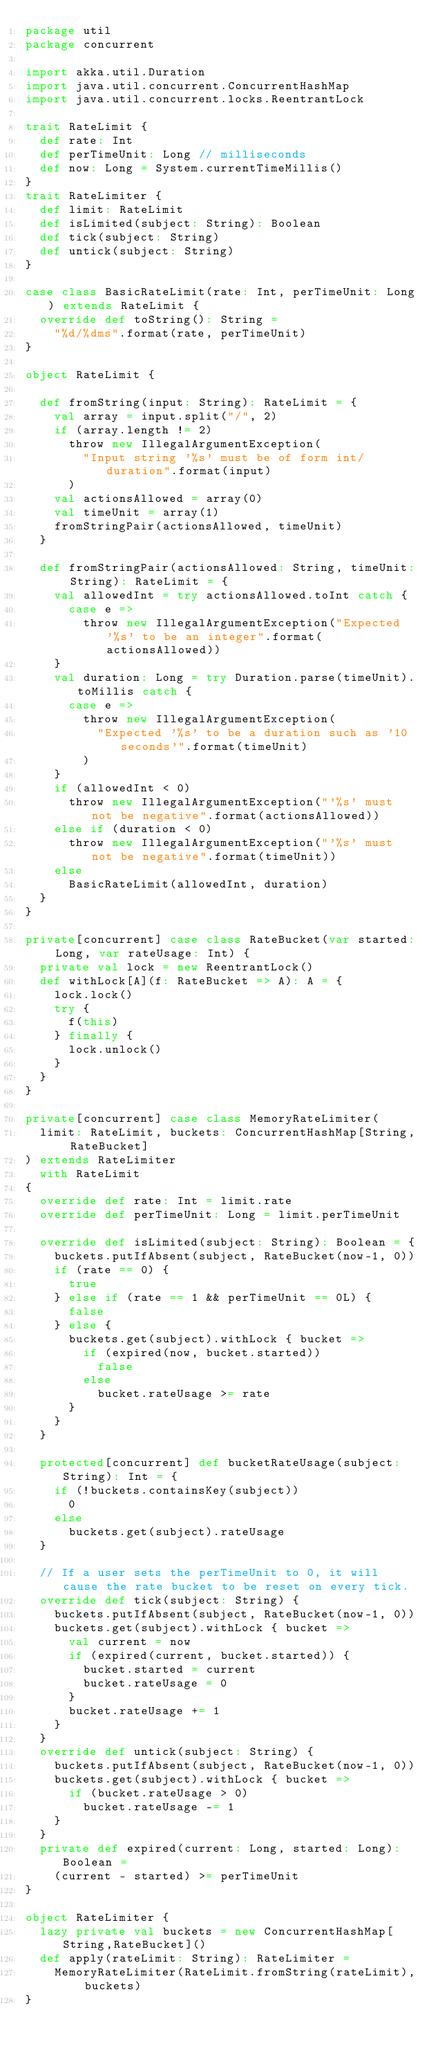<code> <loc_0><loc_0><loc_500><loc_500><_Scala_>package util
package concurrent

import akka.util.Duration
import java.util.concurrent.ConcurrentHashMap
import java.util.concurrent.locks.ReentrantLock

trait RateLimit {
  def rate: Int
  def perTimeUnit: Long // milliseconds
  def now: Long = System.currentTimeMillis()
}
trait RateLimiter {
  def limit: RateLimit
  def isLimited(subject: String): Boolean
  def tick(subject: String)
  def untick(subject: String)
}

case class BasicRateLimit(rate: Int, perTimeUnit: Long) extends RateLimit {
  override def toString(): String =
    "%d/%dms".format(rate, perTimeUnit)
}

object RateLimit {

  def fromString(input: String): RateLimit = {
    val array = input.split("/", 2)
    if (array.length != 2)
      throw new IllegalArgumentException(
        "Input string '%s' must be of form int/duration".format(input)
      )
    val actionsAllowed = array(0)
    val timeUnit = array(1)
    fromStringPair(actionsAllowed, timeUnit)
  }

  def fromStringPair(actionsAllowed: String, timeUnit: String): RateLimit = {
    val allowedInt = try actionsAllowed.toInt catch {
      case e =>
        throw new IllegalArgumentException("Expected '%s' to be an integer".format(actionsAllowed))
    }
    val duration: Long = try Duration.parse(timeUnit).toMillis catch {
      case e =>
        throw new IllegalArgumentException(
          "Expected '%s' to be a duration such as '10 seconds'".format(timeUnit)
        )
    }
    if (allowedInt < 0)
      throw new IllegalArgumentException("'%s' must not be negative".format(actionsAllowed))
    else if (duration < 0)
      throw new IllegalArgumentException("'%s' must not be negative".format(timeUnit))
    else
      BasicRateLimit(allowedInt, duration)
  }
}

private[concurrent] case class RateBucket(var started: Long, var rateUsage: Int) {
  private val lock = new ReentrantLock()
  def withLock[A](f: RateBucket => A): A = {
    lock.lock()
    try {
      f(this)
    } finally {
      lock.unlock()
    }
  }
}

private[concurrent] case class MemoryRateLimiter(
  limit: RateLimit, buckets: ConcurrentHashMap[String, RateBucket]
) extends RateLimiter
  with RateLimit
{
  override def rate: Int = limit.rate
  override def perTimeUnit: Long = limit.perTimeUnit

  override def isLimited(subject: String): Boolean = {
    buckets.putIfAbsent(subject, RateBucket(now-1, 0))
    if (rate == 0) {
      true
    } else if (rate == 1 && perTimeUnit == 0L) {
      false
    } else {
      buckets.get(subject).withLock { bucket =>
        if (expired(now, bucket.started))
          false
        else
          bucket.rateUsage >= rate
      }
    }
  }

  protected[concurrent] def bucketRateUsage(subject: String): Int = {
    if (!buckets.containsKey(subject))
      0
    else
      buckets.get(subject).rateUsage
  }

  // If a user sets the perTimeUnit to 0, it will cause the rate bucket to be reset on every tick.
  override def tick(subject: String) {
    buckets.putIfAbsent(subject, RateBucket(now-1, 0))
    buckets.get(subject).withLock { bucket =>
      val current = now
      if (expired(current, bucket.started)) {
        bucket.started = current
        bucket.rateUsage = 0
      }
      bucket.rateUsage += 1
    }
  }
  override def untick(subject: String) {
    buckets.putIfAbsent(subject, RateBucket(now-1, 0))
    buckets.get(subject).withLock { bucket =>
      if (bucket.rateUsage > 0)
        bucket.rateUsage -= 1
    }
  }
  private def expired(current: Long, started: Long): Boolean =
    (current - started) >= perTimeUnit
}

object RateLimiter {
  lazy private val buckets = new ConcurrentHashMap[String,RateBucket]()
  def apply(rateLimit: String): RateLimiter =
    MemoryRateLimiter(RateLimit.fromString(rateLimit), buckets)
}
</code> 